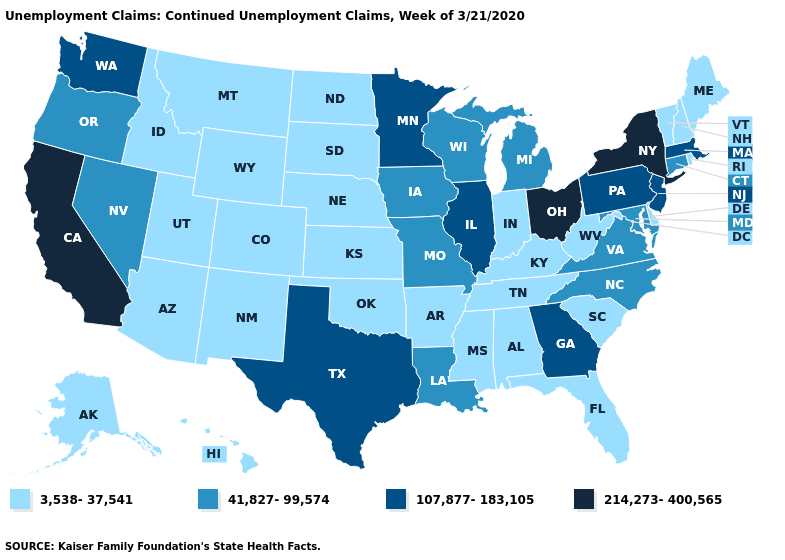What is the value of Maine?
Be succinct. 3,538-37,541. What is the value of South Carolina?
Concise answer only. 3,538-37,541. What is the highest value in the USA?
Give a very brief answer. 214,273-400,565. Does the first symbol in the legend represent the smallest category?
Short answer required. Yes. Name the states that have a value in the range 3,538-37,541?
Write a very short answer. Alabama, Alaska, Arizona, Arkansas, Colorado, Delaware, Florida, Hawaii, Idaho, Indiana, Kansas, Kentucky, Maine, Mississippi, Montana, Nebraska, New Hampshire, New Mexico, North Dakota, Oklahoma, Rhode Island, South Carolina, South Dakota, Tennessee, Utah, Vermont, West Virginia, Wyoming. Does North Dakota have the same value as Iowa?
Give a very brief answer. No. Which states have the lowest value in the USA?
Quick response, please. Alabama, Alaska, Arizona, Arkansas, Colorado, Delaware, Florida, Hawaii, Idaho, Indiana, Kansas, Kentucky, Maine, Mississippi, Montana, Nebraska, New Hampshire, New Mexico, North Dakota, Oklahoma, Rhode Island, South Carolina, South Dakota, Tennessee, Utah, Vermont, West Virginia, Wyoming. What is the value of New Jersey?
Keep it brief. 107,877-183,105. Does the map have missing data?
Answer briefly. No. Does New Hampshire have the lowest value in the Northeast?
Keep it brief. Yes. What is the value of South Dakota?
Short answer required. 3,538-37,541. What is the highest value in states that border Louisiana?
Quick response, please. 107,877-183,105. Name the states that have a value in the range 107,877-183,105?
Quick response, please. Georgia, Illinois, Massachusetts, Minnesota, New Jersey, Pennsylvania, Texas, Washington. Which states have the lowest value in the West?
Be succinct. Alaska, Arizona, Colorado, Hawaii, Idaho, Montana, New Mexico, Utah, Wyoming. Name the states that have a value in the range 107,877-183,105?
Give a very brief answer. Georgia, Illinois, Massachusetts, Minnesota, New Jersey, Pennsylvania, Texas, Washington. 